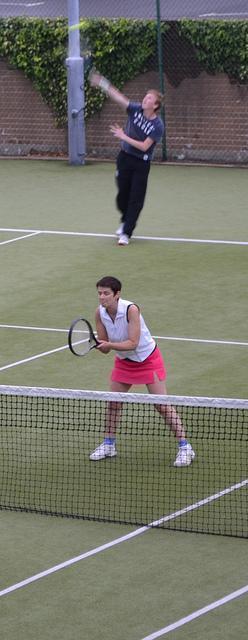What type of tennis are these two players playing?
Indicate the correct choice and explain in the format: 'Answer: answer
Rationale: rationale.'
Options: Mixed doubles, men's doubles, woman's doubles, mixed ages. Answer: mixed doubles.
Rationale: Mixed doubles since one player is a woman. 